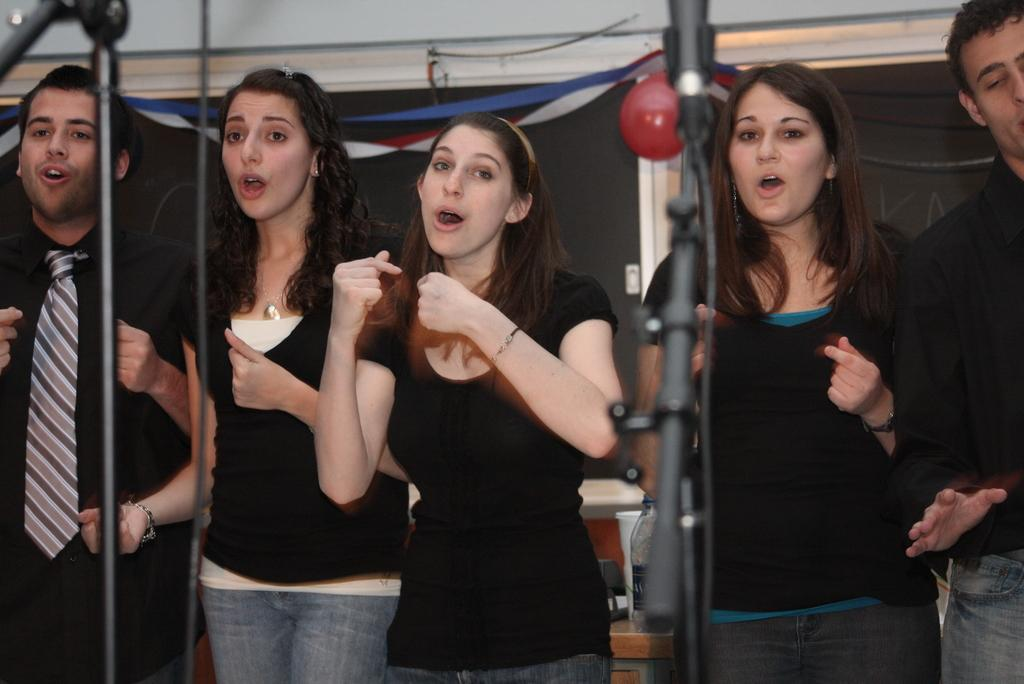What is the main subject of the image? There is a group of people in the image. What objects are in front of the group of people? There are microphones in front of the group of people. What can be seen in the background of the image? There is a balloon and a water bottle in the background of the image. How many pizzas are being held by the person with a finger in the image? There is no person holding pizzas or with a finger in the image. 